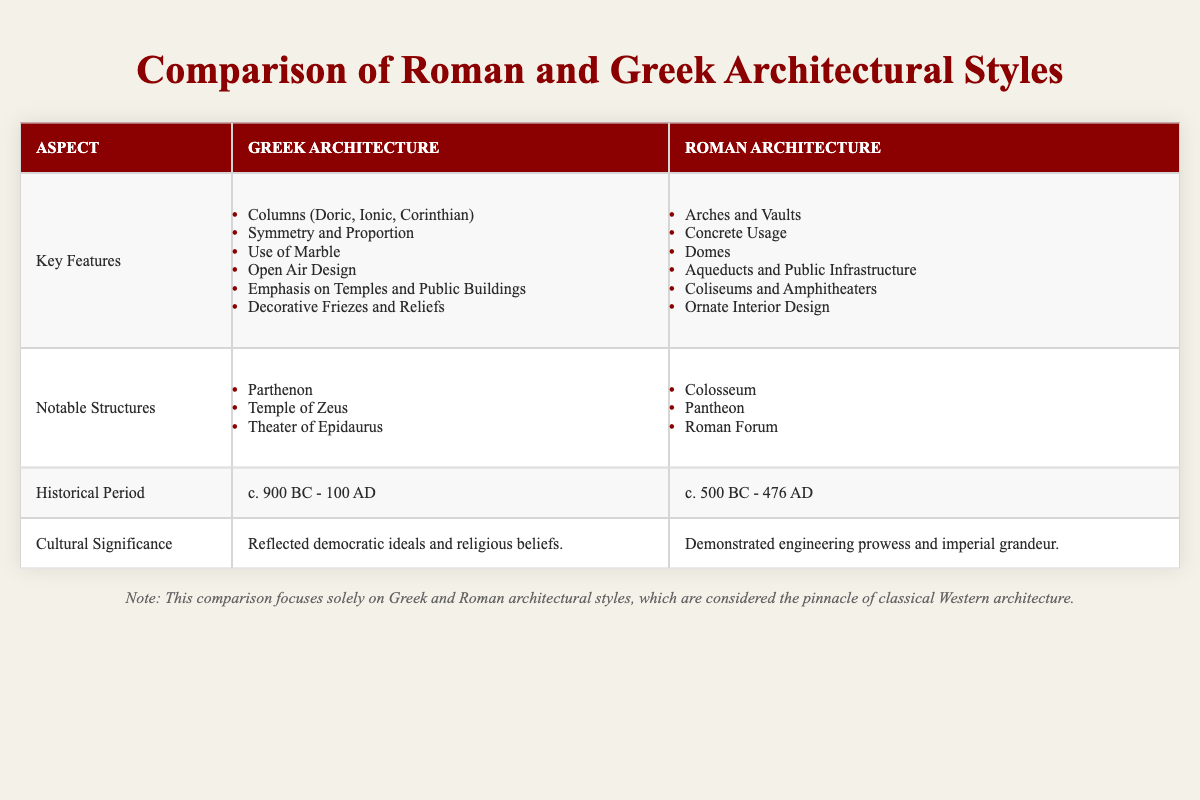What are the key features of Greek architecture? Greek architecture includes several key features such as columns (Doric, Ionic, Corinthian), symmetry and proportion, the use of marble, open-air design, an emphasis on temples and public buildings, and decorative friezes and reliefs. These features highlight the aesthetic principles of Greek civilization.
Answer: Columns, symmetry, marble, open air, temples, friezes What is the historical period of Roman architecture? Roman architecture spans a historical period from approximately 500 BC to 476 AD. This timeframe identifies the era when Roman architectural style evolved and flourished, corresponding to the rise and fall of the Roman Empire.
Answer: c. 500 BC - 476 AD True or False: The Pantheon is a notable structure in Greek architecture. The Pantheon is listed as a notable structure under Roman architecture in the table, not Greek, making the statement false. This can be confirmed by cross-referencing the notable structures listed for each architectural style.
Answer: False What are the cultural significances of Greek and Roman architecture? Greek architecture is culturally significant as it reflects democratic ideals and religious beliefs, whereas Roman architecture demonstrates engineering prowess and imperial grandeur. This comparison shows how each architectural style represented the values and beliefs of its society.
Answer: Greek: democratic ideals; Roman: engineering prowess Which architectural style focuses more on public infrastructure? Roman architecture focuses more on public infrastructure, as indicated by its key features, which include aqueducts and public infrastructure. This aspect showcases the Romans' emphasis on functional infrastructure for public benefit compared to the Greeks.
Answer: Roman architecture What is the average number of notable structures listed for Greek and Roman architecture? Greek architecture lists three notable structures (Parthenon, Temple of Zeus, Theater of Epidaurus) and Roman architecture lists three notable structures (Colosseum, Pantheon, Roman Forum), averaging (3 + 3) / 2 = 3. Therefore, both architectural styles have the same number of notable structures.
Answer: 3 List a feature that is unique to Roman architecture compared to Greek architecture. A unique feature of Roman architecture compared to Greek architecture is the use of concrete, which allowed for the construction of larger and more complex structures like domes and arches. The table specifically highlights this feature as a key aspect of Roman architecture.
Answer: Concrete usage True or False: Both Greek and Roman architecture emphasized the use of columns. While Greek architecture emphasized columns (Doric, Ionic, Corinthian), Roman architecture did not prioritize columns in the same way but included arches and vaults as key features. Thus, it is false to say both emphasized columns equally.
Answer: False What notable structure is an example of Roman engineering prowess? The Colosseum is an example of Roman engineering prowess, as it showcases the Romans' innovative use of arches and concrete. This structure is highlighted in the table under notable structures for Roman architecture, illustrating its significance in showcasing Roman engineering achievements.
Answer: Colosseum 